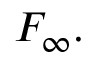Convert formula to latex. <formula><loc_0><loc_0><loc_500><loc_500>F _ { \infty } .</formula> 